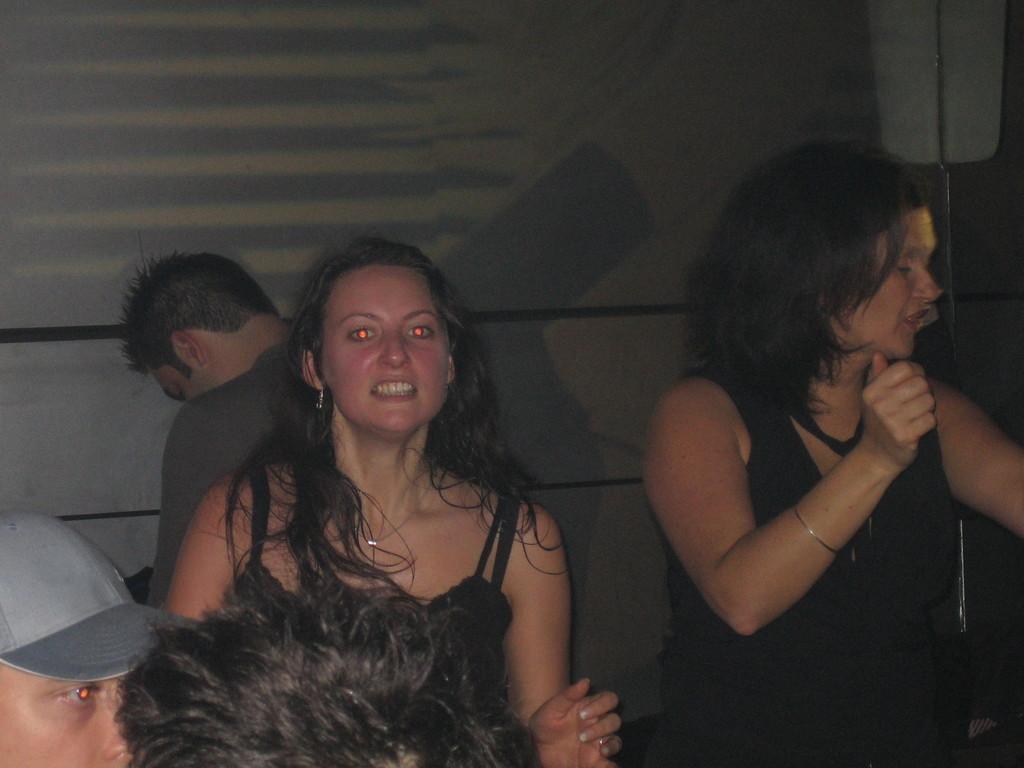How would you summarize this image in a sentence or two? In the middle of the picture, we see two women. Behind them, we see a man. At the bottom, we see the hair of the person and the man is wearing a grey cap. In the background, we see a white wall. On the right side, we see the stand and a board in white color. 